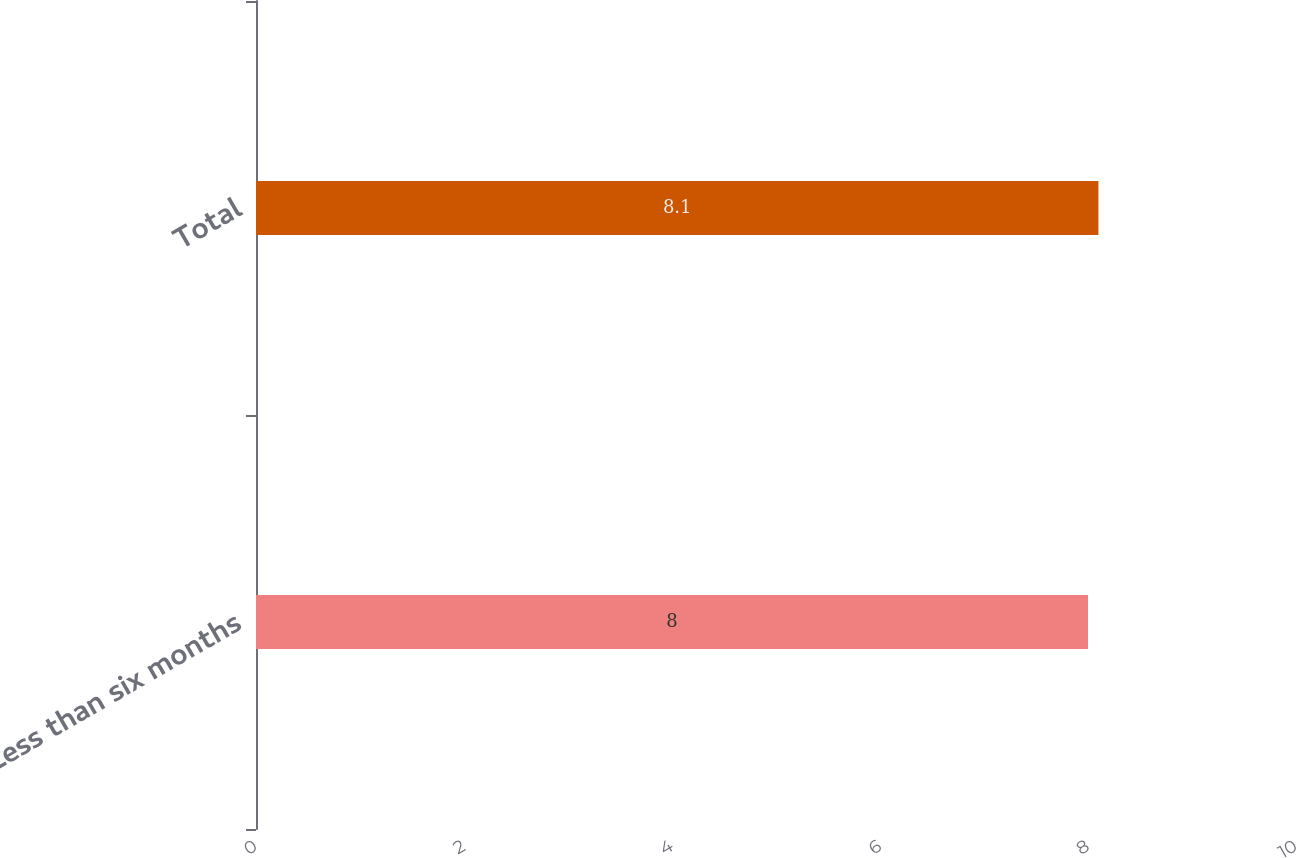<chart> <loc_0><loc_0><loc_500><loc_500><bar_chart><fcel>Less than six months<fcel>Total<nl><fcel>8<fcel>8.1<nl></chart> 